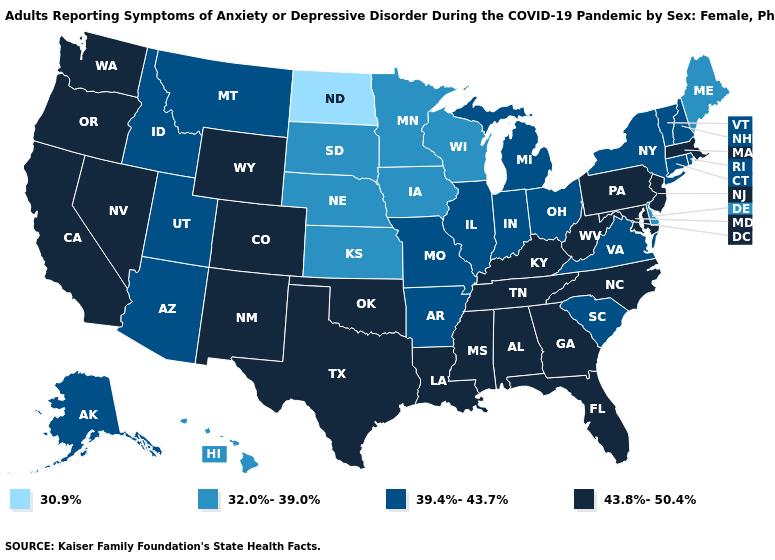Among the states that border Wyoming , which have the highest value?
Concise answer only. Colorado. Does Maine have a lower value than Minnesota?
Short answer required. No. Which states have the lowest value in the MidWest?
Answer briefly. North Dakota. Does the first symbol in the legend represent the smallest category?
Give a very brief answer. Yes. Does Texas have the highest value in the USA?
Write a very short answer. Yes. What is the value of Connecticut?
Keep it brief. 39.4%-43.7%. What is the value of Florida?
Answer briefly. 43.8%-50.4%. Does New Jersey have the lowest value in the USA?
Give a very brief answer. No. What is the value of Utah?
Give a very brief answer. 39.4%-43.7%. What is the lowest value in the MidWest?
Give a very brief answer. 30.9%. Which states have the lowest value in the MidWest?
Quick response, please. North Dakota. Does Minnesota have a lower value than South Dakota?
Quick response, please. No. What is the value of West Virginia?
Be succinct. 43.8%-50.4%. What is the value of New York?
Keep it brief. 39.4%-43.7%. What is the highest value in the Northeast ?
Keep it brief. 43.8%-50.4%. 